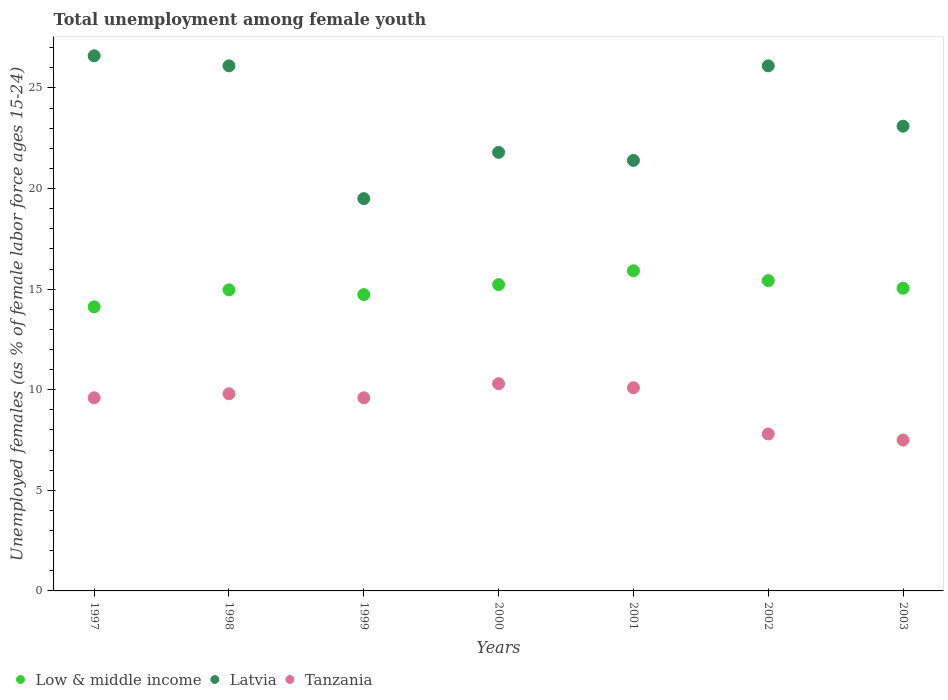How many different coloured dotlines are there?
Ensure brevity in your answer.  3. What is the percentage of unemployed females in in Latvia in 2002?
Your answer should be compact. 26.1. Across all years, what is the maximum percentage of unemployed females in in Latvia?
Keep it short and to the point. 26.6. What is the total percentage of unemployed females in in Latvia in the graph?
Give a very brief answer. 164.6. What is the difference between the percentage of unemployed females in in Tanzania in 2001 and that in 2003?
Offer a very short reply. 2.6. What is the difference between the percentage of unemployed females in in Latvia in 2003 and the percentage of unemployed females in in Tanzania in 2001?
Your answer should be compact. 13. What is the average percentage of unemployed females in in Tanzania per year?
Keep it short and to the point. 9.24. In the year 1998, what is the difference between the percentage of unemployed females in in Latvia and percentage of unemployed females in in Tanzania?
Offer a very short reply. 16.3. In how many years, is the percentage of unemployed females in in Low & middle income greater than 10 %?
Keep it short and to the point. 7. What is the ratio of the percentage of unemployed females in in Latvia in 1999 to that in 2003?
Provide a succinct answer. 0.84. What is the difference between the highest and the second highest percentage of unemployed females in in Low & middle income?
Offer a very short reply. 0.49. What is the difference between the highest and the lowest percentage of unemployed females in in Latvia?
Provide a short and direct response. 7.1. In how many years, is the percentage of unemployed females in in Tanzania greater than the average percentage of unemployed females in in Tanzania taken over all years?
Offer a very short reply. 5. Is the sum of the percentage of unemployed females in in Tanzania in 2000 and 2003 greater than the maximum percentage of unemployed females in in Latvia across all years?
Offer a terse response. No. Does the percentage of unemployed females in in Latvia monotonically increase over the years?
Offer a terse response. No. Is the percentage of unemployed females in in Low & middle income strictly greater than the percentage of unemployed females in in Latvia over the years?
Make the answer very short. No. Is the percentage of unemployed females in in Low & middle income strictly less than the percentage of unemployed females in in Latvia over the years?
Make the answer very short. Yes. How many dotlines are there?
Offer a terse response. 3. What is the difference between two consecutive major ticks on the Y-axis?
Provide a succinct answer. 5. Does the graph contain any zero values?
Give a very brief answer. No. Does the graph contain grids?
Offer a terse response. No. How are the legend labels stacked?
Provide a short and direct response. Horizontal. What is the title of the graph?
Keep it short and to the point. Total unemployment among female youth. Does "Bosnia and Herzegovina" appear as one of the legend labels in the graph?
Give a very brief answer. No. What is the label or title of the Y-axis?
Make the answer very short. Unemployed females (as % of female labor force ages 15-24). What is the Unemployed females (as % of female labor force ages 15-24) in Low & middle income in 1997?
Your response must be concise. 14.12. What is the Unemployed females (as % of female labor force ages 15-24) in Latvia in 1997?
Provide a short and direct response. 26.6. What is the Unemployed females (as % of female labor force ages 15-24) of Tanzania in 1997?
Ensure brevity in your answer.  9.6. What is the Unemployed females (as % of female labor force ages 15-24) of Low & middle income in 1998?
Your answer should be compact. 14.97. What is the Unemployed females (as % of female labor force ages 15-24) in Latvia in 1998?
Your answer should be very brief. 26.1. What is the Unemployed females (as % of female labor force ages 15-24) of Tanzania in 1998?
Your answer should be compact. 9.8. What is the Unemployed females (as % of female labor force ages 15-24) of Low & middle income in 1999?
Offer a very short reply. 14.73. What is the Unemployed females (as % of female labor force ages 15-24) in Latvia in 1999?
Offer a terse response. 19.5. What is the Unemployed females (as % of female labor force ages 15-24) of Tanzania in 1999?
Your answer should be compact. 9.6. What is the Unemployed females (as % of female labor force ages 15-24) of Low & middle income in 2000?
Keep it short and to the point. 15.22. What is the Unemployed females (as % of female labor force ages 15-24) of Latvia in 2000?
Make the answer very short. 21.8. What is the Unemployed females (as % of female labor force ages 15-24) in Tanzania in 2000?
Give a very brief answer. 10.3. What is the Unemployed females (as % of female labor force ages 15-24) of Low & middle income in 2001?
Offer a very short reply. 15.91. What is the Unemployed females (as % of female labor force ages 15-24) in Latvia in 2001?
Offer a terse response. 21.4. What is the Unemployed females (as % of female labor force ages 15-24) in Tanzania in 2001?
Provide a succinct answer. 10.1. What is the Unemployed females (as % of female labor force ages 15-24) of Low & middle income in 2002?
Your answer should be compact. 15.42. What is the Unemployed females (as % of female labor force ages 15-24) in Latvia in 2002?
Keep it short and to the point. 26.1. What is the Unemployed females (as % of female labor force ages 15-24) of Tanzania in 2002?
Give a very brief answer. 7.8. What is the Unemployed females (as % of female labor force ages 15-24) in Low & middle income in 2003?
Offer a very short reply. 15.05. What is the Unemployed females (as % of female labor force ages 15-24) in Latvia in 2003?
Offer a very short reply. 23.1. Across all years, what is the maximum Unemployed females (as % of female labor force ages 15-24) of Low & middle income?
Your answer should be very brief. 15.91. Across all years, what is the maximum Unemployed females (as % of female labor force ages 15-24) in Latvia?
Provide a short and direct response. 26.6. Across all years, what is the maximum Unemployed females (as % of female labor force ages 15-24) of Tanzania?
Give a very brief answer. 10.3. Across all years, what is the minimum Unemployed females (as % of female labor force ages 15-24) in Low & middle income?
Your answer should be compact. 14.12. Across all years, what is the minimum Unemployed females (as % of female labor force ages 15-24) of Latvia?
Ensure brevity in your answer.  19.5. Across all years, what is the minimum Unemployed females (as % of female labor force ages 15-24) of Tanzania?
Give a very brief answer. 7.5. What is the total Unemployed females (as % of female labor force ages 15-24) of Low & middle income in the graph?
Give a very brief answer. 105.42. What is the total Unemployed females (as % of female labor force ages 15-24) of Latvia in the graph?
Make the answer very short. 164.6. What is the total Unemployed females (as % of female labor force ages 15-24) of Tanzania in the graph?
Make the answer very short. 64.7. What is the difference between the Unemployed females (as % of female labor force ages 15-24) of Low & middle income in 1997 and that in 1998?
Make the answer very short. -0.84. What is the difference between the Unemployed females (as % of female labor force ages 15-24) in Latvia in 1997 and that in 1998?
Give a very brief answer. 0.5. What is the difference between the Unemployed females (as % of female labor force ages 15-24) in Low & middle income in 1997 and that in 1999?
Your answer should be very brief. -0.61. What is the difference between the Unemployed females (as % of female labor force ages 15-24) in Latvia in 1997 and that in 1999?
Provide a short and direct response. 7.1. What is the difference between the Unemployed females (as % of female labor force ages 15-24) of Low & middle income in 1997 and that in 2000?
Your answer should be very brief. -1.1. What is the difference between the Unemployed females (as % of female labor force ages 15-24) of Tanzania in 1997 and that in 2000?
Your answer should be very brief. -0.7. What is the difference between the Unemployed females (as % of female labor force ages 15-24) in Low & middle income in 1997 and that in 2001?
Offer a terse response. -1.79. What is the difference between the Unemployed females (as % of female labor force ages 15-24) in Tanzania in 1997 and that in 2001?
Give a very brief answer. -0.5. What is the difference between the Unemployed females (as % of female labor force ages 15-24) of Low & middle income in 1997 and that in 2002?
Your response must be concise. -1.3. What is the difference between the Unemployed females (as % of female labor force ages 15-24) of Low & middle income in 1997 and that in 2003?
Provide a short and direct response. -0.92. What is the difference between the Unemployed females (as % of female labor force ages 15-24) of Low & middle income in 1998 and that in 1999?
Offer a terse response. 0.24. What is the difference between the Unemployed females (as % of female labor force ages 15-24) in Tanzania in 1998 and that in 1999?
Give a very brief answer. 0.2. What is the difference between the Unemployed females (as % of female labor force ages 15-24) in Low & middle income in 1998 and that in 2000?
Ensure brevity in your answer.  -0.26. What is the difference between the Unemployed females (as % of female labor force ages 15-24) of Tanzania in 1998 and that in 2000?
Provide a short and direct response. -0.5. What is the difference between the Unemployed females (as % of female labor force ages 15-24) of Low & middle income in 1998 and that in 2001?
Your response must be concise. -0.95. What is the difference between the Unemployed females (as % of female labor force ages 15-24) in Latvia in 1998 and that in 2001?
Keep it short and to the point. 4.7. What is the difference between the Unemployed females (as % of female labor force ages 15-24) in Tanzania in 1998 and that in 2001?
Keep it short and to the point. -0.3. What is the difference between the Unemployed females (as % of female labor force ages 15-24) in Low & middle income in 1998 and that in 2002?
Make the answer very short. -0.46. What is the difference between the Unemployed females (as % of female labor force ages 15-24) of Low & middle income in 1998 and that in 2003?
Keep it short and to the point. -0.08. What is the difference between the Unemployed females (as % of female labor force ages 15-24) of Latvia in 1998 and that in 2003?
Your answer should be very brief. 3. What is the difference between the Unemployed females (as % of female labor force ages 15-24) of Low & middle income in 1999 and that in 2000?
Your answer should be very brief. -0.5. What is the difference between the Unemployed females (as % of female labor force ages 15-24) of Latvia in 1999 and that in 2000?
Keep it short and to the point. -2.3. What is the difference between the Unemployed females (as % of female labor force ages 15-24) of Low & middle income in 1999 and that in 2001?
Give a very brief answer. -1.18. What is the difference between the Unemployed females (as % of female labor force ages 15-24) of Latvia in 1999 and that in 2001?
Your answer should be compact. -1.9. What is the difference between the Unemployed females (as % of female labor force ages 15-24) of Tanzania in 1999 and that in 2001?
Ensure brevity in your answer.  -0.5. What is the difference between the Unemployed females (as % of female labor force ages 15-24) of Low & middle income in 1999 and that in 2002?
Provide a succinct answer. -0.7. What is the difference between the Unemployed females (as % of female labor force ages 15-24) of Low & middle income in 1999 and that in 2003?
Ensure brevity in your answer.  -0.32. What is the difference between the Unemployed females (as % of female labor force ages 15-24) of Latvia in 1999 and that in 2003?
Give a very brief answer. -3.6. What is the difference between the Unemployed females (as % of female labor force ages 15-24) in Low & middle income in 2000 and that in 2001?
Provide a short and direct response. -0.69. What is the difference between the Unemployed females (as % of female labor force ages 15-24) in Tanzania in 2000 and that in 2001?
Offer a terse response. 0.2. What is the difference between the Unemployed females (as % of female labor force ages 15-24) in Low & middle income in 2000 and that in 2002?
Provide a succinct answer. -0.2. What is the difference between the Unemployed females (as % of female labor force ages 15-24) of Latvia in 2000 and that in 2002?
Offer a terse response. -4.3. What is the difference between the Unemployed females (as % of female labor force ages 15-24) of Tanzania in 2000 and that in 2002?
Your answer should be compact. 2.5. What is the difference between the Unemployed females (as % of female labor force ages 15-24) of Low & middle income in 2000 and that in 2003?
Keep it short and to the point. 0.18. What is the difference between the Unemployed females (as % of female labor force ages 15-24) in Low & middle income in 2001 and that in 2002?
Ensure brevity in your answer.  0.49. What is the difference between the Unemployed females (as % of female labor force ages 15-24) of Latvia in 2001 and that in 2002?
Make the answer very short. -4.7. What is the difference between the Unemployed females (as % of female labor force ages 15-24) in Low & middle income in 2001 and that in 2003?
Keep it short and to the point. 0.87. What is the difference between the Unemployed females (as % of female labor force ages 15-24) in Latvia in 2001 and that in 2003?
Provide a succinct answer. -1.7. What is the difference between the Unemployed females (as % of female labor force ages 15-24) in Low & middle income in 2002 and that in 2003?
Provide a short and direct response. 0.38. What is the difference between the Unemployed females (as % of female labor force ages 15-24) in Latvia in 2002 and that in 2003?
Your answer should be compact. 3. What is the difference between the Unemployed females (as % of female labor force ages 15-24) in Low & middle income in 1997 and the Unemployed females (as % of female labor force ages 15-24) in Latvia in 1998?
Your answer should be compact. -11.98. What is the difference between the Unemployed females (as % of female labor force ages 15-24) in Low & middle income in 1997 and the Unemployed females (as % of female labor force ages 15-24) in Tanzania in 1998?
Make the answer very short. 4.32. What is the difference between the Unemployed females (as % of female labor force ages 15-24) in Latvia in 1997 and the Unemployed females (as % of female labor force ages 15-24) in Tanzania in 1998?
Offer a very short reply. 16.8. What is the difference between the Unemployed females (as % of female labor force ages 15-24) of Low & middle income in 1997 and the Unemployed females (as % of female labor force ages 15-24) of Latvia in 1999?
Keep it short and to the point. -5.38. What is the difference between the Unemployed females (as % of female labor force ages 15-24) in Low & middle income in 1997 and the Unemployed females (as % of female labor force ages 15-24) in Tanzania in 1999?
Your answer should be compact. 4.52. What is the difference between the Unemployed females (as % of female labor force ages 15-24) of Low & middle income in 1997 and the Unemployed females (as % of female labor force ages 15-24) of Latvia in 2000?
Offer a terse response. -7.68. What is the difference between the Unemployed females (as % of female labor force ages 15-24) in Low & middle income in 1997 and the Unemployed females (as % of female labor force ages 15-24) in Tanzania in 2000?
Offer a terse response. 3.82. What is the difference between the Unemployed females (as % of female labor force ages 15-24) of Low & middle income in 1997 and the Unemployed females (as % of female labor force ages 15-24) of Latvia in 2001?
Ensure brevity in your answer.  -7.28. What is the difference between the Unemployed females (as % of female labor force ages 15-24) in Low & middle income in 1997 and the Unemployed females (as % of female labor force ages 15-24) in Tanzania in 2001?
Keep it short and to the point. 4.02. What is the difference between the Unemployed females (as % of female labor force ages 15-24) in Latvia in 1997 and the Unemployed females (as % of female labor force ages 15-24) in Tanzania in 2001?
Ensure brevity in your answer.  16.5. What is the difference between the Unemployed females (as % of female labor force ages 15-24) of Low & middle income in 1997 and the Unemployed females (as % of female labor force ages 15-24) of Latvia in 2002?
Provide a succinct answer. -11.98. What is the difference between the Unemployed females (as % of female labor force ages 15-24) in Low & middle income in 1997 and the Unemployed females (as % of female labor force ages 15-24) in Tanzania in 2002?
Provide a succinct answer. 6.32. What is the difference between the Unemployed females (as % of female labor force ages 15-24) of Latvia in 1997 and the Unemployed females (as % of female labor force ages 15-24) of Tanzania in 2002?
Your answer should be very brief. 18.8. What is the difference between the Unemployed females (as % of female labor force ages 15-24) of Low & middle income in 1997 and the Unemployed females (as % of female labor force ages 15-24) of Latvia in 2003?
Provide a succinct answer. -8.98. What is the difference between the Unemployed females (as % of female labor force ages 15-24) in Low & middle income in 1997 and the Unemployed females (as % of female labor force ages 15-24) in Tanzania in 2003?
Ensure brevity in your answer.  6.62. What is the difference between the Unemployed females (as % of female labor force ages 15-24) in Low & middle income in 1998 and the Unemployed females (as % of female labor force ages 15-24) in Latvia in 1999?
Make the answer very short. -4.53. What is the difference between the Unemployed females (as % of female labor force ages 15-24) of Low & middle income in 1998 and the Unemployed females (as % of female labor force ages 15-24) of Tanzania in 1999?
Keep it short and to the point. 5.37. What is the difference between the Unemployed females (as % of female labor force ages 15-24) in Low & middle income in 1998 and the Unemployed females (as % of female labor force ages 15-24) in Latvia in 2000?
Offer a terse response. -6.83. What is the difference between the Unemployed females (as % of female labor force ages 15-24) of Low & middle income in 1998 and the Unemployed females (as % of female labor force ages 15-24) of Tanzania in 2000?
Offer a very short reply. 4.67. What is the difference between the Unemployed females (as % of female labor force ages 15-24) in Latvia in 1998 and the Unemployed females (as % of female labor force ages 15-24) in Tanzania in 2000?
Your answer should be compact. 15.8. What is the difference between the Unemployed females (as % of female labor force ages 15-24) of Low & middle income in 1998 and the Unemployed females (as % of female labor force ages 15-24) of Latvia in 2001?
Your answer should be compact. -6.43. What is the difference between the Unemployed females (as % of female labor force ages 15-24) in Low & middle income in 1998 and the Unemployed females (as % of female labor force ages 15-24) in Tanzania in 2001?
Your response must be concise. 4.87. What is the difference between the Unemployed females (as % of female labor force ages 15-24) in Latvia in 1998 and the Unemployed females (as % of female labor force ages 15-24) in Tanzania in 2001?
Your answer should be very brief. 16. What is the difference between the Unemployed females (as % of female labor force ages 15-24) in Low & middle income in 1998 and the Unemployed females (as % of female labor force ages 15-24) in Latvia in 2002?
Give a very brief answer. -11.13. What is the difference between the Unemployed females (as % of female labor force ages 15-24) of Low & middle income in 1998 and the Unemployed females (as % of female labor force ages 15-24) of Tanzania in 2002?
Provide a succinct answer. 7.17. What is the difference between the Unemployed females (as % of female labor force ages 15-24) in Latvia in 1998 and the Unemployed females (as % of female labor force ages 15-24) in Tanzania in 2002?
Keep it short and to the point. 18.3. What is the difference between the Unemployed females (as % of female labor force ages 15-24) of Low & middle income in 1998 and the Unemployed females (as % of female labor force ages 15-24) of Latvia in 2003?
Offer a very short reply. -8.13. What is the difference between the Unemployed females (as % of female labor force ages 15-24) in Low & middle income in 1998 and the Unemployed females (as % of female labor force ages 15-24) in Tanzania in 2003?
Your answer should be compact. 7.47. What is the difference between the Unemployed females (as % of female labor force ages 15-24) in Latvia in 1998 and the Unemployed females (as % of female labor force ages 15-24) in Tanzania in 2003?
Give a very brief answer. 18.6. What is the difference between the Unemployed females (as % of female labor force ages 15-24) in Low & middle income in 1999 and the Unemployed females (as % of female labor force ages 15-24) in Latvia in 2000?
Your answer should be very brief. -7.07. What is the difference between the Unemployed females (as % of female labor force ages 15-24) of Low & middle income in 1999 and the Unemployed females (as % of female labor force ages 15-24) of Tanzania in 2000?
Provide a short and direct response. 4.43. What is the difference between the Unemployed females (as % of female labor force ages 15-24) in Low & middle income in 1999 and the Unemployed females (as % of female labor force ages 15-24) in Latvia in 2001?
Keep it short and to the point. -6.67. What is the difference between the Unemployed females (as % of female labor force ages 15-24) in Low & middle income in 1999 and the Unemployed females (as % of female labor force ages 15-24) in Tanzania in 2001?
Your answer should be very brief. 4.63. What is the difference between the Unemployed females (as % of female labor force ages 15-24) of Latvia in 1999 and the Unemployed females (as % of female labor force ages 15-24) of Tanzania in 2001?
Provide a short and direct response. 9.4. What is the difference between the Unemployed females (as % of female labor force ages 15-24) in Low & middle income in 1999 and the Unemployed females (as % of female labor force ages 15-24) in Latvia in 2002?
Your answer should be compact. -11.37. What is the difference between the Unemployed females (as % of female labor force ages 15-24) in Low & middle income in 1999 and the Unemployed females (as % of female labor force ages 15-24) in Tanzania in 2002?
Your answer should be very brief. 6.93. What is the difference between the Unemployed females (as % of female labor force ages 15-24) in Latvia in 1999 and the Unemployed females (as % of female labor force ages 15-24) in Tanzania in 2002?
Offer a terse response. 11.7. What is the difference between the Unemployed females (as % of female labor force ages 15-24) of Low & middle income in 1999 and the Unemployed females (as % of female labor force ages 15-24) of Latvia in 2003?
Your answer should be compact. -8.37. What is the difference between the Unemployed females (as % of female labor force ages 15-24) of Low & middle income in 1999 and the Unemployed females (as % of female labor force ages 15-24) of Tanzania in 2003?
Give a very brief answer. 7.23. What is the difference between the Unemployed females (as % of female labor force ages 15-24) in Low & middle income in 2000 and the Unemployed females (as % of female labor force ages 15-24) in Latvia in 2001?
Offer a very short reply. -6.18. What is the difference between the Unemployed females (as % of female labor force ages 15-24) in Low & middle income in 2000 and the Unemployed females (as % of female labor force ages 15-24) in Tanzania in 2001?
Your answer should be very brief. 5.12. What is the difference between the Unemployed females (as % of female labor force ages 15-24) in Low & middle income in 2000 and the Unemployed females (as % of female labor force ages 15-24) in Latvia in 2002?
Offer a very short reply. -10.88. What is the difference between the Unemployed females (as % of female labor force ages 15-24) of Low & middle income in 2000 and the Unemployed females (as % of female labor force ages 15-24) of Tanzania in 2002?
Keep it short and to the point. 7.42. What is the difference between the Unemployed females (as % of female labor force ages 15-24) of Latvia in 2000 and the Unemployed females (as % of female labor force ages 15-24) of Tanzania in 2002?
Ensure brevity in your answer.  14. What is the difference between the Unemployed females (as % of female labor force ages 15-24) in Low & middle income in 2000 and the Unemployed females (as % of female labor force ages 15-24) in Latvia in 2003?
Give a very brief answer. -7.88. What is the difference between the Unemployed females (as % of female labor force ages 15-24) in Low & middle income in 2000 and the Unemployed females (as % of female labor force ages 15-24) in Tanzania in 2003?
Give a very brief answer. 7.72. What is the difference between the Unemployed females (as % of female labor force ages 15-24) of Low & middle income in 2001 and the Unemployed females (as % of female labor force ages 15-24) of Latvia in 2002?
Your answer should be very brief. -10.19. What is the difference between the Unemployed females (as % of female labor force ages 15-24) in Low & middle income in 2001 and the Unemployed females (as % of female labor force ages 15-24) in Tanzania in 2002?
Your answer should be compact. 8.11. What is the difference between the Unemployed females (as % of female labor force ages 15-24) of Low & middle income in 2001 and the Unemployed females (as % of female labor force ages 15-24) of Latvia in 2003?
Ensure brevity in your answer.  -7.19. What is the difference between the Unemployed females (as % of female labor force ages 15-24) in Low & middle income in 2001 and the Unemployed females (as % of female labor force ages 15-24) in Tanzania in 2003?
Make the answer very short. 8.41. What is the difference between the Unemployed females (as % of female labor force ages 15-24) in Low & middle income in 2002 and the Unemployed females (as % of female labor force ages 15-24) in Latvia in 2003?
Your response must be concise. -7.68. What is the difference between the Unemployed females (as % of female labor force ages 15-24) in Low & middle income in 2002 and the Unemployed females (as % of female labor force ages 15-24) in Tanzania in 2003?
Offer a terse response. 7.92. What is the difference between the Unemployed females (as % of female labor force ages 15-24) in Latvia in 2002 and the Unemployed females (as % of female labor force ages 15-24) in Tanzania in 2003?
Your response must be concise. 18.6. What is the average Unemployed females (as % of female labor force ages 15-24) in Low & middle income per year?
Your answer should be compact. 15.06. What is the average Unemployed females (as % of female labor force ages 15-24) in Latvia per year?
Keep it short and to the point. 23.51. What is the average Unemployed females (as % of female labor force ages 15-24) of Tanzania per year?
Make the answer very short. 9.24. In the year 1997, what is the difference between the Unemployed females (as % of female labor force ages 15-24) of Low & middle income and Unemployed females (as % of female labor force ages 15-24) of Latvia?
Ensure brevity in your answer.  -12.48. In the year 1997, what is the difference between the Unemployed females (as % of female labor force ages 15-24) in Low & middle income and Unemployed females (as % of female labor force ages 15-24) in Tanzania?
Your answer should be very brief. 4.52. In the year 1998, what is the difference between the Unemployed females (as % of female labor force ages 15-24) in Low & middle income and Unemployed females (as % of female labor force ages 15-24) in Latvia?
Keep it short and to the point. -11.13. In the year 1998, what is the difference between the Unemployed females (as % of female labor force ages 15-24) of Low & middle income and Unemployed females (as % of female labor force ages 15-24) of Tanzania?
Your answer should be compact. 5.17. In the year 1998, what is the difference between the Unemployed females (as % of female labor force ages 15-24) in Latvia and Unemployed females (as % of female labor force ages 15-24) in Tanzania?
Ensure brevity in your answer.  16.3. In the year 1999, what is the difference between the Unemployed females (as % of female labor force ages 15-24) in Low & middle income and Unemployed females (as % of female labor force ages 15-24) in Latvia?
Keep it short and to the point. -4.77. In the year 1999, what is the difference between the Unemployed females (as % of female labor force ages 15-24) of Low & middle income and Unemployed females (as % of female labor force ages 15-24) of Tanzania?
Offer a terse response. 5.13. In the year 1999, what is the difference between the Unemployed females (as % of female labor force ages 15-24) of Latvia and Unemployed females (as % of female labor force ages 15-24) of Tanzania?
Offer a very short reply. 9.9. In the year 2000, what is the difference between the Unemployed females (as % of female labor force ages 15-24) in Low & middle income and Unemployed females (as % of female labor force ages 15-24) in Latvia?
Ensure brevity in your answer.  -6.58. In the year 2000, what is the difference between the Unemployed females (as % of female labor force ages 15-24) in Low & middle income and Unemployed females (as % of female labor force ages 15-24) in Tanzania?
Provide a succinct answer. 4.92. In the year 2001, what is the difference between the Unemployed females (as % of female labor force ages 15-24) in Low & middle income and Unemployed females (as % of female labor force ages 15-24) in Latvia?
Offer a terse response. -5.49. In the year 2001, what is the difference between the Unemployed females (as % of female labor force ages 15-24) of Low & middle income and Unemployed females (as % of female labor force ages 15-24) of Tanzania?
Your response must be concise. 5.81. In the year 2001, what is the difference between the Unemployed females (as % of female labor force ages 15-24) in Latvia and Unemployed females (as % of female labor force ages 15-24) in Tanzania?
Ensure brevity in your answer.  11.3. In the year 2002, what is the difference between the Unemployed females (as % of female labor force ages 15-24) in Low & middle income and Unemployed females (as % of female labor force ages 15-24) in Latvia?
Make the answer very short. -10.68. In the year 2002, what is the difference between the Unemployed females (as % of female labor force ages 15-24) in Low & middle income and Unemployed females (as % of female labor force ages 15-24) in Tanzania?
Provide a succinct answer. 7.62. In the year 2002, what is the difference between the Unemployed females (as % of female labor force ages 15-24) of Latvia and Unemployed females (as % of female labor force ages 15-24) of Tanzania?
Provide a short and direct response. 18.3. In the year 2003, what is the difference between the Unemployed females (as % of female labor force ages 15-24) of Low & middle income and Unemployed females (as % of female labor force ages 15-24) of Latvia?
Give a very brief answer. -8.05. In the year 2003, what is the difference between the Unemployed females (as % of female labor force ages 15-24) of Low & middle income and Unemployed females (as % of female labor force ages 15-24) of Tanzania?
Your answer should be very brief. 7.55. What is the ratio of the Unemployed females (as % of female labor force ages 15-24) of Low & middle income in 1997 to that in 1998?
Your response must be concise. 0.94. What is the ratio of the Unemployed females (as % of female labor force ages 15-24) of Latvia in 1997 to that in 1998?
Offer a very short reply. 1.02. What is the ratio of the Unemployed females (as % of female labor force ages 15-24) in Tanzania in 1997 to that in 1998?
Give a very brief answer. 0.98. What is the ratio of the Unemployed females (as % of female labor force ages 15-24) in Low & middle income in 1997 to that in 1999?
Make the answer very short. 0.96. What is the ratio of the Unemployed females (as % of female labor force ages 15-24) of Latvia in 1997 to that in 1999?
Your answer should be compact. 1.36. What is the ratio of the Unemployed females (as % of female labor force ages 15-24) of Tanzania in 1997 to that in 1999?
Offer a very short reply. 1. What is the ratio of the Unemployed females (as % of female labor force ages 15-24) in Low & middle income in 1997 to that in 2000?
Offer a terse response. 0.93. What is the ratio of the Unemployed females (as % of female labor force ages 15-24) of Latvia in 1997 to that in 2000?
Give a very brief answer. 1.22. What is the ratio of the Unemployed females (as % of female labor force ages 15-24) in Tanzania in 1997 to that in 2000?
Your answer should be very brief. 0.93. What is the ratio of the Unemployed females (as % of female labor force ages 15-24) in Low & middle income in 1997 to that in 2001?
Provide a succinct answer. 0.89. What is the ratio of the Unemployed females (as % of female labor force ages 15-24) in Latvia in 1997 to that in 2001?
Your answer should be very brief. 1.24. What is the ratio of the Unemployed females (as % of female labor force ages 15-24) in Tanzania in 1997 to that in 2001?
Ensure brevity in your answer.  0.95. What is the ratio of the Unemployed females (as % of female labor force ages 15-24) of Low & middle income in 1997 to that in 2002?
Provide a succinct answer. 0.92. What is the ratio of the Unemployed females (as % of female labor force ages 15-24) of Latvia in 1997 to that in 2002?
Provide a short and direct response. 1.02. What is the ratio of the Unemployed females (as % of female labor force ages 15-24) in Tanzania in 1997 to that in 2002?
Your answer should be compact. 1.23. What is the ratio of the Unemployed females (as % of female labor force ages 15-24) in Low & middle income in 1997 to that in 2003?
Your response must be concise. 0.94. What is the ratio of the Unemployed females (as % of female labor force ages 15-24) of Latvia in 1997 to that in 2003?
Your response must be concise. 1.15. What is the ratio of the Unemployed females (as % of female labor force ages 15-24) of Tanzania in 1997 to that in 2003?
Offer a very short reply. 1.28. What is the ratio of the Unemployed females (as % of female labor force ages 15-24) of Low & middle income in 1998 to that in 1999?
Make the answer very short. 1.02. What is the ratio of the Unemployed females (as % of female labor force ages 15-24) of Latvia in 1998 to that in 1999?
Make the answer very short. 1.34. What is the ratio of the Unemployed females (as % of female labor force ages 15-24) in Tanzania in 1998 to that in 1999?
Your response must be concise. 1.02. What is the ratio of the Unemployed females (as % of female labor force ages 15-24) of Low & middle income in 1998 to that in 2000?
Offer a very short reply. 0.98. What is the ratio of the Unemployed females (as % of female labor force ages 15-24) in Latvia in 1998 to that in 2000?
Give a very brief answer. 1.2. What is the ratio of the Unemployed females (as % of female labor force ages 15-24) of Tanzania in 1998 to that in 2000?
Ensure brevity in your answer.  0.95. What is the ratio of the Unemployed females (as % of female labor force ages 15-24) in Low & middle income in 1998 to that in 2001?
Your response must be concise. 0.94. What is the ratio of the Unemployed females (as % of female labor force ages 15-24) of Latvia in 1998 to that in 2001?
Provide a succinct answer. 1.22. What is the ratio of the Unemployed females (as % of female labor force ages 15-24) in Tanzania in 1998 to that in 2001?
Provide a short and direct response. 0.97. What is the ratio of the Unemployed females (as % of female labor force ages 15-24) of Low & middle income in 1998 to that in 2002?
Give a very brief answer. 0.97. What is the ratio of the Unemployed females (as % of female labor force ages 15-24) of Latvia in 1998 to that in 2002?
Your answer should be compact. 1. What is the ratio of the Unemployed females (as % of female labor force ages 15-24) of Tanzania in 1998 to that in 2002?
Your response must be concise. 1.26. What is the ratio of the Unemployed females (as % of female labor force ages 15-24) in Low & middle income in 1998 to that in 2003?
Make the answer very short. 0.99. What is the ratio of the Unemployed females (as % of female labor force ages 15-24) in Latvia in 1998 to that in 2003?
Offer a very short reply. 1.13. What is the ratio of the Unemployed females (as % of female labor force ages 15-24) of Tanzania in 1998 to that in 2003?
Keep it short and to the point. 1.31. What is the ratio of the Unemployed females (as % of female labor force ages 15-24) in Low & middle income in 1999 to that in 2000?
Your answer should be compact. 0.97. What is the ratio of the Unemployed females (as % of female labor force ages 15-24) of Latvia in 1999 to that in 2000?
Make the answer very short. 0.89. What is the ratio of the Unemployed females (as % of female labor force ages 15-24) of Tanzania in 1999 to that in 2000?
Make the answer very short. 0.93. What is the ratio of the Unemployed females (as % of female labor force ages 15-24) of Low & middle income in 1999 to that in 2001?
Provide a succinct answer. 0.93. What is the ratio of the Unemployed females (as % of female labor force ages 15-24) in Latvia in 1999 to that in 2001?
Give a very brief answer. 0.91. What is the ratio of the Unemployed females (as % of female labor force ages 15-24) of Tanzania in 1999 to that in 2001?
Keep it short and to the point. 0.95. What is the ratio of the Unemployed females (as % of female labor force ages 15-24) of Low & middle income in 1999 to that in 2002?
Your response must be concise. 0.95. What is the ratio of the Unemployed females (as % of female labor force ages 15-24) of Latvia in 1999 to that in 2002?
Offer a very short reply. 0.75. What is the ratio of the Unemployed females (as % of female labor force ages 15-24) in Tanzania in 1999 to that in 2002?
Offer a terse response. 1.23. What is the ratio of the Unemployed females (as % of female labor force ages 15-24) of Low & middle income in 1999 to that in 2003?
Your answer should be compact. 0.98. What is the ratio of the Unemployed females (as % of female labor force ages 15-24) of Latvia in 1999 to that in 2003?
Your answer should be compact. 0.84. What is the ratio of the Unemployed females (as % of female labor force ages 15-24) in Tanzania in 1999 to that in 2003?
Your answer should be very brief. 1.28. What is the ratio of the Unemployed females (as % of female labor force ages 15-24) of Low & middle income in 2000 to that in 2001?
Keep it short and to the point. 0.96. What is the ratio of the Unemployed females (as % of female labor force ages 15-24) in Latvia in 2000 to that in 2001?
Your answer should be compact. 1.02. What is the ratio of the Unemployed females (as % of female labor force ages 15-24) in Tanzania in 2000 to that in 2001?
Your answer should be compact. 1.02. What is the ratio of the Unemployed females (as % of female labor force ages 15-24) in Low & middle income in 2000 to that in 2002?
Your answer should be very brief. 0.99. What is the ratio of the Unemployed females (as % of female labor force ages 15-24) in Latvia in 2000 to that in 2002?
Provide a succinct answer. 0.84. What is the ratio of the Unemployed females (as % of female labor force ages 15-24) in Tanzania in 2000 to that in 2002?
Your answer should be compact. 1.32. What is the ratio of the Unemployed females (as % of female labor force ages 15-24) of Low & middle income in 2000 to that in 2003?
Offer a very short reply. 1.01. What is the ratio of the Unemployed females (as % of female labor force ages 15-24) in Latvia in 2000 to that in 2003?
Ensure brevity in your answer.  0.94. What is the ratio of the Unemployed females (as % of female labor force ages 15-24) in Tanzania in 2000 to that in 2003?
Offer a terse response. 1.37. What is the ratio of the Unemployed females (as % of female labor force ages 15-24) in Low & middle income in 2001 to that in 2002?
Provide a succinct answer. 1.03. What is the ratio of the Unemployed females (as % of female labor force ages 15-24) in Latvia in 2001 to that in 2002?
Offer a terse response. 0.82. What is the ratio of the Unemployed females (as % of female labor force ages 15-24) of Tanzania in 2001 to that in 2002?
Keep it short and to the point. 1.29. What is the ratio of the Unemployed females (as % of female labor force ages 15-24) in Low & middle income in 2001 to that in 2003?
Give a very brief answer. 1.06. What is the ratio of the Unemployed females (as % of female labor force ages 15-24) of Latvia in 2001 to that in 2003?
Give a very brief answer. 0.93. What is the ratio of the Unemployed females (as % of female labor force ages 15-24) in Tanzania in 2001 to that in 2003?
Your answer should be very brief. 1.35. What is the ratio of the Unemployed females (as % of female labor force ages 15-24) of Low & middle income in 2002 to that in 2003?
Your answer should be very brief. 1.03. What is the ratio of the Unemployed females (as % of female labor force ages 15-24) in Latvia in 2002 to that in 2003?
Ensure brevity in your answer.  1.13. What is the ratio of the Unemployed females (as % of female labor force ages 15-24) of Tanzania in 2002 to that in 2003?
Your answer should be compact. 1.04. What is the difference between the highest and the second highest Unemployed females (as % of female labor force ages 15-24) of Low & middle income?
Your answer should be compact. 0.49. What is the difference between the highest and the second highest Unemployed females (as % of female labor force ages 15-24) of Tanzania?
Make the answer very short. 0.2. What is the difference between the highest and the lowest Unemployed females (as % of female labor force ages 15-24) in Low & middle income?
Give a very brief answer. 1.79. 